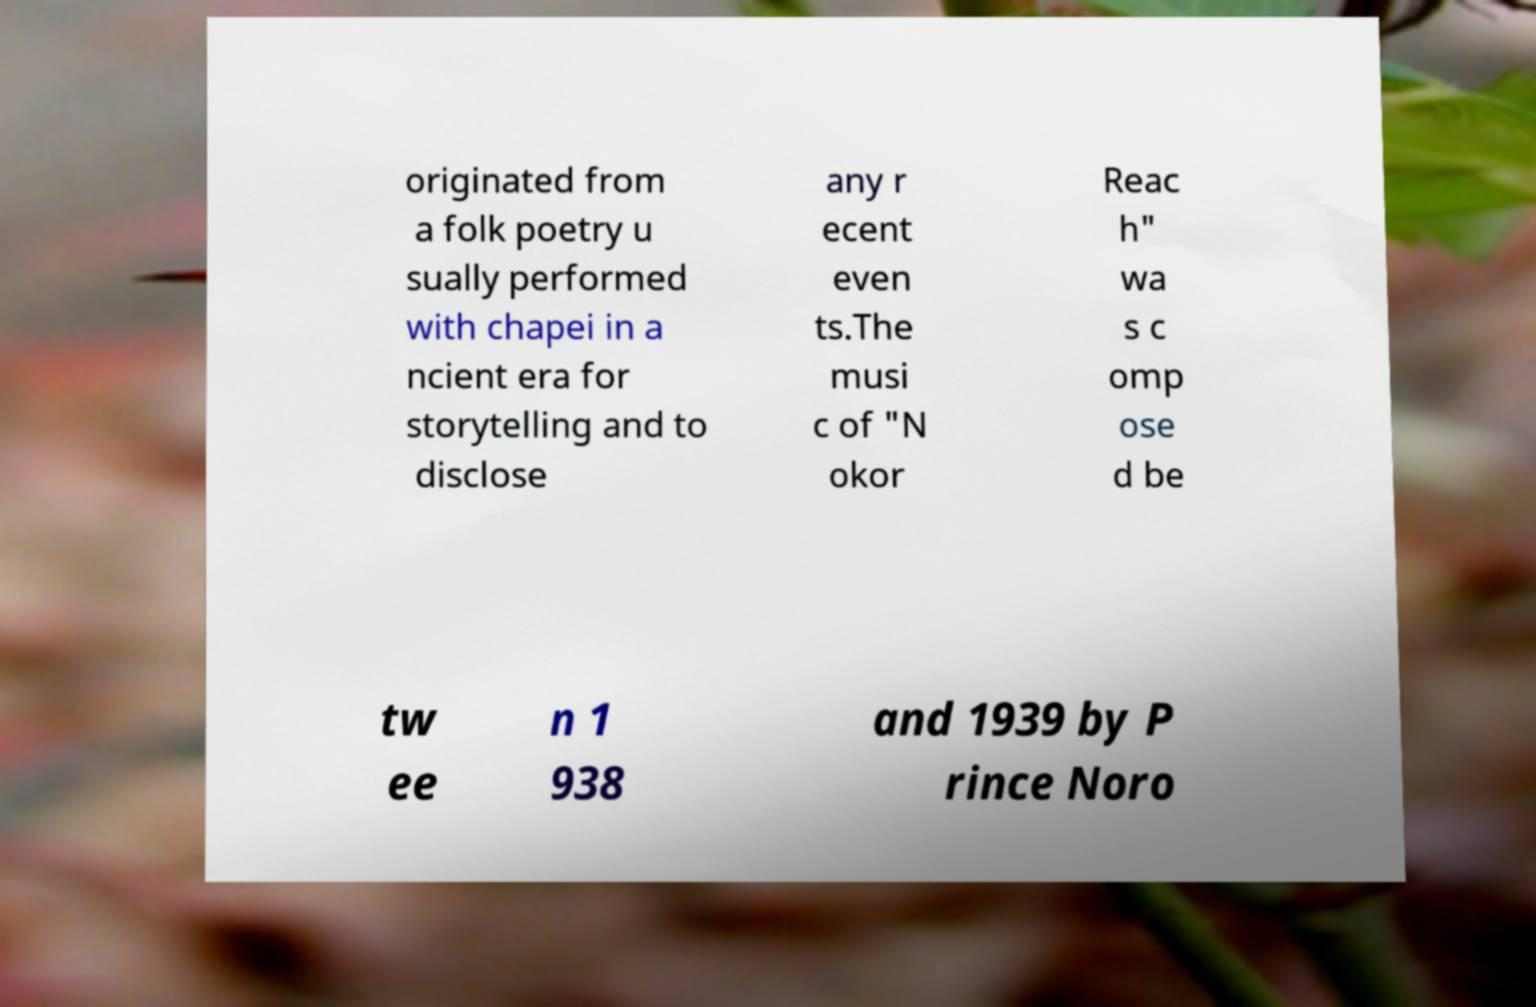Could you extract and type out the text from this image? originated from a folk poetry u sually performed with chapei in a ncient era for storytelling and to disclose any r ecent even ts.The musi c of "N okor Reac h" wa s c omp ose d be tw ee n 1 938 and 1939 by P rince Noro 